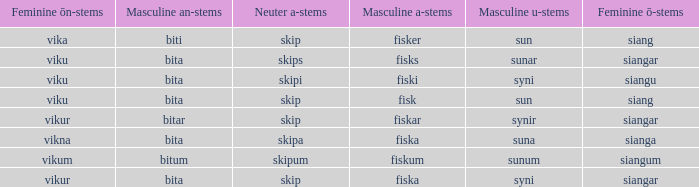What is the masculine u form for the old Swedish word with a neuter a form of skipum? Sunum. 